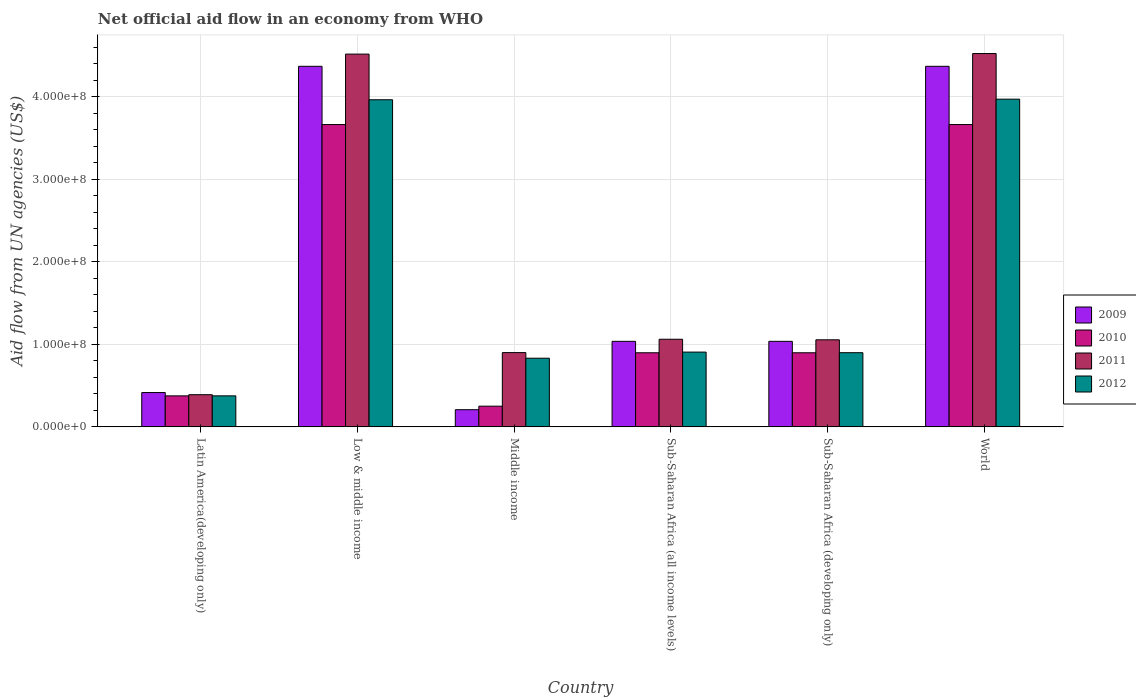How many groups of bars are there?
Make the answer very short. 6. Are the number of bars on each tick of the X-axis equal?
Make the answer very short. Yes. How many bars are there on the 5th tick from the left?
Offer a terse response. 4. How many bars are there on the 1st tick from the right?
Your response must be concise. 4. What is the label of the 4th group of bars from the left?
Your answer should be very brief. Sub-Saharan Africa (all income levels). In how many cases, is the number of bars for a given country not equal to the number of legend labels?
Keep it short and to the point. 0. What is the net official aid flow in 2009 in Sub-Saharan Africa (developing only)?
Make the answer very short. 1.04e+08. Across all countries, what is the maximum net official aid flow in 2009?
Ensure brevity in your answer.  4.37e+08. Across all countries, what is the minimum net official aid flow in 2012?
Your answer should be very brief. 3.76e+07. In which country was the net official aid flow in 2011 minimum?
Provide a succinct answer. Latin America(developing only). What is the total net official aid flow in 2011 in the graph?
Provide a succinct answer. 1.24e+09. What is the difference between the net official aid flow in 2009 in Low & middle income and that in Sub-Saharan Africa (all income levels)?
Your response must be concise. 3.33e+08. What is the difference between the net official aid flow in 2009 in Sub-Saharan Africa (developing only) and the net official aid flow in 2011 in World?
Provide a succinct answer. -3.49e+08. What is the average net official aid flow in 2010 per country?
Offer a very short reply. 1.62e+08. What is the difference between the net official aid flow of/in 2012 and net official aid flow of/in 2011 in Latin America(developing only)?
Offer a very short reply. -1.40e+06. What is the ratio of the net official aid flow in 2011 in Sub-Saharan Africa (all income levels) to that in Sub-Saharan Africa (developing only)?
Give a very brief answer. 1.01. Is the net official aid flow in 2011 in Latin America(developing only) less than that in Sub-Saharan Africa (developing only)?
Keep it short and to the point. Yes. What is the difference between the highest and the second highest net official aid flow in 2009?
Your answer should be compact. 3.33e+08. What is the difference between the highest and the lowest net official aid flow in 2011?
Your answer should be very brief. 4.13e+08. Is the sum of the net official aid flow in 2009 in Latin America(developing only) and World greater than the maximum net official aid flow in 2011 across all countries?
Provide a short and direct response. Yes. Is it the case that in every country, the sum of the net official aid flow in 2009 and net official aid flow in 2012 is greater than the sum of net official aid flow in 2011 and net official aid flow in 2010?
Offer a very short reply. No. How many bars are there?
Your response must be concise. 24. What is the difference between two consecutive major ticks on the Y-axis?
Make the answer very short. 1.00e+08. Does the graph contain grids?
Your answer should be very brief. Yes. How many legend labels are there?
Make the answer very short. 4. How are the legend labels stacked?
Keep it short and to the point. Vertical. What is the title of the graph?
Your answer should be very brief. Net official aid flow in an economy from WHO. What is the label or title of the Y-axis?
Keep it short and to the point. Aid flow from UN agencies (US$). What is the Aid flow from UN agencies (US$) of 2009 in Latin America(developing only)?
Offer a very short reply. 4.16e+07. What is the Aid flow from UN agencies (US$) of 2010 in Latin America(developing only)?
Offer a terse response. 3.76e+07. What is the Aid flow from UN agencies (US$) of 2011 in Latin America(developing only)?
Your response must be concise. 3.90e+07. What is the Aid flow from UN agencies (US$) in 2012 in Latin America(developing only)?
Your answer should be compact. 3.76e+07. What is the Aid flow from UN agencies (US$) in 2009 in Low & middle income?
Provide a succinct answer. 4.37e+08. What is the Aid flow from UN agencies (US$) of 2010 in Low & middle income?
Your answer should be very brief. 3.66e+08. What is the Aid flow from UN agencies (US$) of 2011 in Low & middle income?
Offer a terse response. 4.52e+08. What is the Aid flow from UN agencies (US$) in 2012 in Low & middle income?
Keep it short and to the point. 3.96e+08. What is the Aid flow from UN agencies (US$) in 2009 in Middle income?
Provide a short and direct response. 2.08e+07. What is the Aid flow from UN agencies (US$) in 2010 in Middle income?
Provide a short and direct response. 2.51e+07. What is the Aid flow from UN agencies (US$) of 2011 in Middle income?
Your answer should be compact. 9.00e+07. What is the Aid flow from UN agencies (US$) of 2012 in Middle income?
Provide a succinct answer. 8.32e+07. What is the Aid flow from UN agencies (US$) in 2009 in Sub-Saharan Africa (all income levels)?
Your answer should be very brief. 1.04e+08. What is the Aid flow from UN agencies (US$) in 2010 in Sub-Saharan Africa (all income levels)?
Provide a succinct answer. 8.98e+07. What is the Aid flow from UN agencies (US$) in 2011 in Sub-Saharan Africa (all income levels)?
Give a very brief answer. 1.06e+08. What is the Aid flow from UN agencies (US$) in 2012 in Sub-Saharan Africa (all income levels)?
Ensure brevity in your answer.  9.06e+07. What is the Aid flow from UN agencies (US$) of 2009 in Sub-Saharan Africa (developing only)?
Offer a very short reply. 1.04e+08. What is the Aid flow from UN agencies (US$) of 2010 in Sub-Saharan Africa (developing only)?
Give a very brief answer. 8.98e+07. What is the Aid flow from UN agencies (US$) in 2011 in Sub-Saharan Africa (developing only)?
Offer a very short reply. 1.05e+08. What is the Aid flow from UN agencies (US$) in 2012 in Sub-Saharan Africa (developing only)?
Provide a short and direct response. 8.98e+07. What is the Aid flow from UN agencies (US$) of 2009 in World?
Offer a very short reply. 4.37e+08. What is the Aid flow from UN agencies (US$) of 2010 in World?
Your answer should be very brief. 3.66e+08. What is the Aid flow from UN agencies (US$) in 2011 in World?
Give a very brief answer. 4.52e+08. What is the Aid flow from UN agencies (US$) of 2012 in World?
Your answer should be very brief. 3.97e+08. Across all countries, what is the maximum Aid flow from UN agencies (US$) of 2009?
Offer a terse response. 4.37e+08. Across all countries, what is the maximum Aid flow from UN agencies (US$) of 2010?
Your answer should be very brief. 3.66e+08. Across all countries, what is the maximum Aid flow from UN agencies (US$) of 2011?
Offer a terse response. 4.52e+08. Across all countries, what is the maximum Aid flow from UN agencies (US$) in 2012?
Make the answer very short. 3.97e+08. Across all countries, what is the minimum Aid flow from UN agencies (US$) in 2009?
Keep it short and to the point. 2.08e+07. Across all countries, what is the minimum Aid flow from UN agencies (US$) in 2010?
Ensure brevity in your answer.  2.51e+07. Across all countries, what is the minimum Aid flow from UN agencies (US$) of 2011?
Ensure brevity in your answer.  3.90e+07. Across all countries, what is the minimum Aid flow from UN agencies (US$) of 2012?
Make the answer very short. 3.76e+07. What is the total Aid flow from UN agencies (US$) of 2009 in the graph?
Your answer should be very brief. 1.14e+09. What is the total Aid flow from UN agencies (US$) of 2010 in the graph?
Keep it short and to the point. 9.75e+08. What is the total Aid flow from UN agencies (US$) of 2011 in the graph?
Ensure brevity in your answer.  1.24e+09. What is the total Aid flow from UN agencies (US$) of 2012 in the graph?
Give a very brief answer. 1.09e+09. What is the difference between the Aid flow from UN agencies (US$) of 2009 in Latin America(developing only) and that in Low & middle income?
Give a very brief answer. -3.95e+08. What is the difference between the Aid flow from UN agencies (US$) of 2010 in Latin America(developing only) and that in Low & middle income?
Ensure brevity in your answer.  -3.29e+08. What is the difference between the Aid flow from UN agencies (US$) of 2011 in Latin America(developing only) and that in Low & middle income?
Give a very brief answer. -4.13e+08. What is the difference between the Aid flow from UN agencies (US$) in 2012 in Latin America(developing only) and that in Low & middle income?
Your response must be concise. -3.59e+08. What is the difference between the Aid flow from UN agencies (US$) of 2009 in Latin America(developing only) and that in Middle income?
Your answer should be compact. 2.08e+07. What is the difference between the Aid flow from UN agencies (US$) of 2010 in Latin America(developing only) and that in Middle income?
Keep it short and to the point. 1.25e+07. What is the difference between the Aid flow from UN agencies (US$) in 2011 in Latin America(developing only) and that in Middle income?
Keep it short and to the point. -5.10e+07. What is the difference between the Aid flow from UN agencies (US$) of 2012 in Latin America(developing only) and that in Middle income?
Offer a very short reply. -4.56e+07. What is the difference between the Aid flow from UN agencies (US$) in 2009 in Latin America(developing only) and that in Sub-Saharan Africa (all income levels)?
Provide a succinct answer. -6.20e+07. What is the difference between the Aid flow from UN agencies (US$) of 2010 in Latin America(developing only) and that in Sub-Saharan Africa (all income levels)?
Keep it short and to the point. -5.22e+07. What is the difference between the Aid flow from UN agencies (US$) of 2011 in Latin America(developing only) and that in Sub-Saharan Africa (all income levels)?
Give a very brief answer. -6.72e+07. What is the difference between the Aid flow from UN agencies (US$) in 2012 in Latin America(developing only) and that in Sub-Saharan Africa (all income levels)?
Keep it short and to the point. -5.30e+07. What is the difference between the Aid flow from UN agencies (US$) in 2009 in Latin America(developing only) and that in Sub-Saharan Africa (developing only)?
Ensure brevity in your answer.  -6.20e+07. What is the difference between the Aid flow from UN agencies (US$) in 2010 in Latin America(developing only) and that in Sub-Saharan Africa (developing only)?
Your answer should be very brief. -5.22e+07. What is the difference between the Aid flow from UN agencies (US$) in 2011 in Latin America(developing only) and that in Sub-Saharan Africa (developing only)?
Offer a very short reply. -6.65e+07. What is the difference between the Aid flow from UN agencies (US$) of 2012 in Latin America(developing only) and that in Sub-Saharan Africa (developing only)?
Keep it short and to the point. -5.23e+07. What is the difference between the Aid flow from UN agencies (US$) of 2009 in Latin America(developing only) and that in World?
Your answer should be very brief. -3.95e+08. What is the difference between the Aid flow from UN agencies (US$) of 2010 in Latin America(developing only) and that in World?
Your response must be concise. -3.29e+08. What is the difference between the Aid flow from UN agencies (US$) in 2011 in Latin America(developing only) and that in World?
Provide a succinct answer. -4.13e+08. What is the difference between the Aid flow from UN agencies (US$) of 2012 in Latin America(developing only) and that in World?
Your answer should be very brief. -3.59e+08. What is the difference between the Aid flow from UN agencies (US$) of 2009 in Low & middle income and that in Middle income?
Make the answer very short. 4.16e+08. What is the difference between the Aid flow from UN agencies (US$) in 2010 in Low & middle income and that in Middle income?
Ensure brevity in your answer.  3.41e+08. What is the difference between the Aid flow from UN agencies (US$) of 2011 in Low & middle income and that in Middle income?
Keep it short and to the point. 3.62e+08. What is the difference between the Aid flow from UN agencies (US$) of 2012 in Low & middle income and that in Middle income?
Your answer should be very brief. 3.13e+08. What is the difference between the Aid flow from UN agencies (US$) in 2009 in Low & middle income and that in Sub-Saharan Africa (all income levels)?
Your answer should be compact. 3.33e+08. What is the difference between the Aid flow from UN agencies (US$) of 2010 in Low & middle income and that in Sub-Saharan Africa (all income levels)?
Your response must be concise. 2.76e+08. What is the difference between the Aid flow from UN agencies (US$) of 2011 in Low & middle income and that in Sub-Saharan Africa (all income levels)?
Offer a very short reply. 3.45e+08. What is the difference between the Aid flow from UN agencies (US$) in 2012 in Low & middle income and that in Sub-Saharan Africa (all income levels)?
Offer a very short reply. 3.06e+08. What is the difference between the Aid flow from UN agencies (US$) of 2009 in Low & middle income and that in Sub-Saharan Africa (developing only)?
Offer a terse response. 3.33e+08. What is the difference between the Aid flow from UN agencies (US$) of 2010 in Low & middle income and that in Sub-Saharan Africa (developing only)?
Your answer should be compact. 2.76e+08. What is the difference between the Aid flow from UN agencies (US$) in 2011 in Low & middle income and that in Sub-Saharan Africa (developing only)?
Ensure brevity in your answer.  3.46e+08. What is the difference between the Aid flow from UN agencies (US$) of 2012 in Low & middle income and that in Sub-Saharan Africa (developing only)?
Keep it short and to the point. 3.06e+08. What is the difference between the Aid flow from UN agencies (US$) in 2009 in Low & middle income and that in World?
Keep it short and to the point. 0. What is the difference between the Aid flow from UN agencies (US$) in 2011 in Low & middle income and that in World?
Your response must be concise. -6.70e+05. What is the difference between the Aid flow from UN agencies (US$) of 2012 in Low & middle income and that in World?
Offer a very short reply. -7.20e+05. What is the difference between the Aid flow from UN agencies (US$) of 2009 in Middle income and that in Sub-Saharan Africa (all income levels)?
Make the answer very short. -8.28e+07. What is the difference between the Aid flow from UN agencies (US$) in 2010 in Middle income and that in Sub-Saharan Africa (all income levels)?
Keep it short and to the point. -6.47e+07. What is the difference between the Aid flow from UN agencies (US$) of 2011 in Middle income and that in Sub-Saharan Africa (all income levels)?
Provide a succinct answer. -1.62e+07. What is the difference between the Aid flow from UN agencies (US$) of 2012 in Middle income and that in Sub-Saharan Africa (all income levels)?
Keep it short and to the point. -7.39e+06. What is the difference between the Aid flow from UN agencies (US$) in 2009 in Middle income and that in Sub-Saharan Africa (developing only)?
Ensure brevity in your answer.  -8.28e+07. What is the difference between the Aid flow from UN agencies (US$) in 2010 in Middle income and that in Sub-Saharan Africa (developing only)?
Provide a succinct answer. -6.47e+07. What is the difference between the Aid flow from UN agencies (US$) of 2011 in Middle income and that in Sub-Saharan Africa (developing only)?
Ensure brevity in your answer.  -1.55e+07. What is the difference between the Aid flow from UN agencies (US$) in 2012 in Middle income and that in Sub-Saharan Africa (developing only)?
Give a very brief answer. -6.67e+06. What is the difference between the Aid flow from UN agencies (US$) of 2009 in Middle income and that in World?
Keep it short and to the point. -4.16e+08. What is the difference between the Aid flow from UN agencies (US$) of 2010 in Middle income and that in World?
Offer a terse response. -3.41e+08. What is the difference between the Aid flow from UN agencies (US$) of 2011 in Middle income and that in World?
Keep it short and to the point. -3.62e+08. What is the difference between the Aid flow from UN agencies (US$) of 2012 in Middle income and that in World?
Keep it short and to the point. -3.14e+08. What is the difference between the Aid flow from UN agencies (US$) in 2009 in Sub-Saharan Africa (all income levels) and that in Sub-Saharan Africa (developing only)?
Offer a very short reply. 0. What is the difference between the Aid flow from UN agencies (US$) in 2010 in Sub-Saharan Africa (all income levels) and that in Sub-Saharan Africa (developing only)?
Offer a very short reply. 0. What is the difference between the Aid flow from UN agencies (US$) in 2011 in Sub-Saharan Africa (all income levels) and that in Sub-Saharan Africa (developing only)?
Your response must be concise. 6.70e+05. What is the difference between the Aid flow from UN agencies (US$) in 2012 in Sub-Saharan Africa (all income levels) and that in Sub-Saharan Africa (developing only)?
Your answer should be very brief. 7.20e+05. What is the difference between the Aid flow from UN agencies (US$) in 2009 in Sub-Saharan Africa (all income levels) and that in World?
Ensure brevity in your answer.  -3.33e+08. What is the difference between the Aid flow from UN agencies (US$) of 2010 in Sub-Saharan Africa (all income levels) and that in World?
Ensure brevity in your answer.  -2.76e+08. What is the difference between the Aid flow from UN agencies (US$) in 2011 in Sub-Saharan Africa (all income levels) and that in World?
Offer a terse response. -3.46e+08. What is the difference between the Aid flow from UN agencies (US$) of 2012 in Sub-Saharan Africa (all income levels) and that in World?
Ensure brevity in your answer.  -3.06e+08. What is the difference between the Aid flow from UN agencies (US$) in 2009 in Sub-Saharan Africa (developing only) and that in World?
Provide a short and direct response. -3.33e+08. What is the difference between the Aid flow from UN agencies (US$) in 2010 in Sub-Saharan Africa (developing only) and that in World?
Your answer should be very brief. -2.76e+08. What is the difference between the Aid flow from UN agencies (US$) of 2011 in Sub-Saharan Africa (developing only) and that in World?
Your answer should be very brief. -3.47e+08. What is the difference between the Aid flow from UN agencies (US$) of 2012 in Sub-Saharan Africa (developing only) and that in World?
Ensure brevity in your answer.  -3.07e+08. What is the difference between the Aid flow from UN agencies (US$) of 2009 in Latin America(developing only) and the Aid flow from UN agencies (US$) of 2010 in Low & middle income?
Make the answer very short. -3.25e+08. What is the difference between the Aid flow from UN agencies (US$) of 2009 in Latin America(developing only) and the Aid flow from UN agencies (US$) of 2011 in Low & middle income?
Offer a very short reply. -4.10e+08. What is the difference between the Aid flow from UN agencies (US$) of 2009 in Latin America(developing only) and the Aid flow from UN agencies (US$) of 2012 in Low & middle income?
Provide a succinct answer. -3.55e+08. What is the difference between the Aid flow from UN agencies (US$) of 2010 in Latin America(developing only) and the Aid flow from UN agencies (US$) of 2011 in Low & middle income?
Make the answer very short. -4.14e+08. What is the difference between the Aid flow from UN agencies (US$) of 2010 in Latin America(developing only) and the Aid flow from UN agencies (US$) of 2012 in Low & middle income?
Your answer should be compact. -3.59e+08. What is the difference between the Aid flow from UN agencies (US$) of 2011 in Latin America(developing only) and the Aid flow from UN agencies (US$) of 2012 in Low & middle income?
Provide a short and direct response. -3.57e+08. What is the difference between the Aid flow from UN agencies (US$) of 2009 in Latin America(developing only) and the Aid flow from UN agencies (US$) of 2010 in Middle income?
Keep it short and to the point. 1.65e+07. What is the difference between the Aid flow from UN agencies (US$) in 2009 in Latin America(developing only) and the Aid flow from UN agencies (US$) in 2011 in Middle income?
Provide a succinct answer. -4.84e+07. What is the difference between the Aid flow from UN agencies (US$) in 2009 in Latin America(developing only) and the Aid flow from UN agencies (US$) in 2012 in Middle income?
Provide a succinct answer. -4.16e+07. What is the difference between the Aid flow from UN agencies (US$) of 2010 in Latin America(developing only) and the Aid flow from UN agencies (US$) of 2011 in Middle income?
Provide a succinct answer. -5.24e+07. What is the difference between the Aid flow from UN agencies (US$) in 2010 in Latin America(developing only) and the Aid flow from UN agencies (US$) in 2012 in Middle income?
Your response must be concise. -4.56e+07. What is the difference between the Aid flow from UN agencies (US$) of 2011 in Latin America(developing only) and the Aid flow from UN agencies (US$) of 2012 in Middle income?
Your answer should be very brief. -4.42e+07. What is the difference between the Aid flow from UN agencies (US$) in 2009 in Latin America(developing only) and the Aid flow from UN agencies (US$) in 2010 in Sub-Saharan Africa (all income levels)?
Provide a succinct answer. -4.82e+07. What is the difference between the Aid flow from UN agencies (US$) of 2009 in Latin America(developing only) and the Aid flow from UN agencies (US$) of 2011 in Sub-Saharan Africa (all income levels)?
Offer a very short reply. -6.46e+07. What is the difference between the Aid flow from UN agencies (US$) in 2009 in Latin America(developing only) and the Aid flow from UN agencies (US$) in 2012 in Sub-Saharan Africa (all income levels)?
Your answer should be very brief. -4.90e+07. What is the difference between the Aid flow from UN agencies (US$) of 2010 in Latin America(developing only) and the Aid flow from UN agencies (US$) of 2011 in Sub-Saharan Africa (all income levels)?
Your answer should be very brief. -6.86e+07. What is the difference between the Aid flow from UN agencies (US$) of 2010 in Latin America(developing only) and the Aid flow from UN agencies (US$) of 2012 in Sub-Saharan Africa (all income levels)?
Provide a succinct answer. -5.30e+07. What is the difference between the Aid flow from UN agencies (US$) of 2011 in Latin America(developing only) and the Aid flow from UN agencies (US$) of 2012 in Sub-Saharan Africa (all income levels)?
Keep it short and to the point. -5.16e+07. What is the difference between the Aid flow from UN agencies (US$) of 2009 in Latin America(developing only) and the Aid flow from UN agencies (US$) of 2010 in Sub-Saharan Africa (developing only)?
Your answer should be compact. -4.82e+07. What is the difference between the Aid flow from UN agencies (US$) of 2009 in Latin America(developing only) and the Aid flow from UN agencies (US$) of 2011 in Sub-Saharan Africa (developing only)?
Offer a terse response. -6.39e+07. What is the difference between the Aid flow from UN agencies (US$) of 2009 in Latin America(developing only) and the Aid flow from UN agencies (US$) of 2012 in Sub-Saharan Africa (developing only)?
Your answer should be very brief. -4.83e+07. What is the difference between the Aid flow from UN agencies (US$) of 2010 in Latin America(developing only) and the Aid flow from UN agencies (US$) of 2011 in Sub-Saharan Africa (developing only)?
Provide a short and direct response. -6.79e+07. What is the difference between the Aid flow from UN agencies (US$) of 2010 in Latin America(developing only) and the Aid flow from UN agencies (US$) of 2012 in Sub-Saharan Africa (developing only)?
Make the answer very short. -5.23e+07. What is the difference between the Aid flow from UN agencies (US$) of 2011 in Latin America(developing only) and the Aid flow from UN agencies (US$) of 2012 in Sub-Saharan Africa (developing only)?
Provide a short and direct response. -5.09e+07. What is the difference between the Aid flow from UN agencies (US$) in 2009 in Latin America(developing only) and the Aid flow from UN agencies (US$) in 2010 in World?
Offer a very short reply. -3.25e+08. What is the difference between the Aid flow from UN agencies (US$) of 2009 in Latin America(developing only) and the Aid flow from UN agencies (US$) of 2011 in World?
Keep it short and to the point. -4.11e+08. What is the difference between the Aid flow from UN agencies (US$) of 2009 in Latin America(developing only) and the Aid flow from UN agencies (US$) of 2012 in World?
Make the answer very short. -3.55e+08. What is the difference between the Aid flow from UN agencies (US$) in 2010 in Latin America(developing only) and the Aid flow from UN agencies (US$) in 2011 in World?
Ensure brevity in your answer.  -4.15e+08. What is the difference between the Aid flow from UN agencies (US$) of 2010 in Latin America(developing only) and the Aid flow from UN agencies (US$) of 2012 in World?
Provide a short and direct response. -3.59e+08. What is the difference between the Aid flow from UN agencies (US$) in 2011 in Latin America(developing only) and the Aid flow from UN agencies (US$) in 2012 in World?
Offer a terse response. -3.58e+08. What is the difference between the Aid flow from UN agencies (US$) in 2009 in Low & middle income and the Aid flow from UN agencies (US$) in 2010 in Middle income?
Offer a terse response. 4.12e+08. What is the difference between the Aid flow from UN agencies (US$) of 2009 in Low & middle income and the Aid flow from UN agencies (US$) of 2011 in Middle income?
Your answer should be compact. 3.47e+08. What is the difference between the Aid flow from UN agencies (US$) in 2009 in Low & middle income and the Aid flow from UN agencies (US$) in 2012 in Middle income?
Provide a succinct answer. 3.54e+08. What is the difference between the Aid flow from UN agencies (US$) in 2010 in Low & middle income and the Aid flow from UN agencies (US$) in 2011 in Middle income?
Your response must be concise. 2.76e+08. What is the difference between the Aid flow from UN agencies (US$) of 2010 in Low & middle income and the Aid flow from UN agencies (US$) of 2012 in Middle income?
Your answer should be compact. 2.83e+08. What is the difference between the Aid flow from UN agencies (US$) of 2011 in Low & middle income and the Aid flow from UN agencies (US$) of 2012 in Middle income?
Provide a short and direct response. 3.68e+08. What is the difference between the Aid flow from UN agencies (US$) of 2009 in Low & middle income and the Aid flow from UN agencies (US$) of 2010 in Sub-Saharan Africa (all income levels)?
Your answer should be compact. 3.47e+08. What is the difference between the Aid flow from UN agencies (US$) in 2009 in Low & middle income and the Aid flow from UN agencies (US$) in 2011 in Sub-Saharan Africa (all income levels)?
Keep it short and to the point. 3.31e+08. What is the difference between the Aid flow from UN agencies (US$) of 2009 in Low & middle income and the Aid flow from UN agencies (US$) of 2012 in Sub-Saharan Africa (all income levels)?
Provide a short and direct response. 3.46e+08. What is the difference between the Aid flow from UN agencies (US$) of 2010 in Low & middle income and the Aid flow from UN agencies (US$) of 2011 in Sub-Saharan Africa (all income levels)?
Give a very brief answer. 2.60e+08. What is the difference between the Aid flow from UN agencies (US$) in 2010 in Low & middle income and the Aid flow from UN agencies (US$) in 2012 in Sub-Saharan Africa (all income levels)?
Ensure brevity in your answer.  2.76e+08. What is the difference between the Aid flow from UN agencies (US$) in 2011 in Low & middle income and the Aid flow from UN agencies (US$) in 2012 in Sub-Saharan Africa (all income levels)?
Offer a terse response. 3.61e+08. What is the difference between the Aid flow from UN agencies (US$) in 2009 in Low & middle income and the Aid flow from UN agencies (US$) in 2010 in Sub-Saharan Africa (developing only)?
Provide a succinct answer. 3.47e+08. What is the difference between the Aid flow from UN agencies (US$) of 2009 in Low & middle income and the Aid flow from UN agencies (US$) of 2011 in Sub-Saharan Africa (developing only)?
Keep it short and to the point. 3.31e+08. What is the difference between the Aid flow from UN agencies (US$) of 2009 in Low & middle income and the Aid flow from UN agencies (US$) of 2012 in Sub-Saharan Africa (developing only)?
Keep it short and to the point. 3.47e+08. What is the difference between the Aid flow from UN agencies (US$) in 2010 in Low & middle income and the Aid flow from UN agencies (US$) in 2011 in Sub-Saharan Africa (developing only)?
Your response must be concise. 2.61e+08. What is the difference between the Aid flow from UN agencies (US$) of 2010 in Low & middle income and the Aid flow from UN agencies (US$) of 2012 in Sub-Saharan Africa (developing only)?
Your answer should be compact. 2.76e+08. What is the difference between the Aid flow from UN agencies (US$) of 2011 in Low & middle income and the Aid flow from UN agencies (US$) of 2012 in Sub-Saharan Africa (developing only)?
Your answer should be compact. 3.62e+08. What is the difference between the Aid flow from UN agencies (US$) of 2009 in Low & middle income and the Aid flow from UN agencies (US$) of 2010 in World?
Make the answer very short. 7.06e+07. What is the difference between the Aid flow from UN agencies (US$) in 2009 in Low & middle income and the Aid flow from UN agencies (US$) in 2011 in World?
Your answer should be very brief. -1.55e+07. What is the difference between the Aid flow from UN agencies (US$) in 2009 in Low & middle income and the Aid flow from UN agencies (US$) in 2012 in World?
Provide a succinct answer. 3.98e+07. What is the difference between the Aid flow from UN agencies (US$) in 2010 in Low & middle income and the Aid flow from UN agencies (US$) in 2011 in World?
Provide a short and direct response. -8.60e+07. What is the difference between the Aid flow from UN agencies (US$) in 2010 in Low & middle income and the Aid flow from UN agencies (US$) in 2012 in World?
Your answer should be compact. -3.08e+07. What is the difference between the Aid flow from UN agencies (US$) of 2011 in Low & middle income and the Aid flow from UN agencies (US$) of 2012 in World?
Your answer should be compact. 5.46e+07. What is the difference between the Aid flow from UN agencies (US$) of 2009 in Middle income and the Aid flow from UN agencies (US$) of 2010 in Sub-Saharan Africa (all income levels)?
Provide a short and direct response. -6.90e+07. What is the difference between the Aid flow from UN agencies (US$) of 2009 in Middle income and the Aid flow from UN agencies (US$) of 2011 in Sub-Saharan Africa (all income levels)?
Keep it short and to the point. -8.54e+07. What is the difference between the Aid flow from UN agencies (US$) of 2009 in Middle income and the Aid flow from UN agencies (US$) of 2012 in Sub-Saharan Africa (all income levels)?
Give a very brief answer. -6.98e+07. What is the difference between the Aid flow from UN agencies (US$) in 2010 in Middle income and the Aid flow from UN agencies (US$) in 2011 in Sub-Saharan Africa (all income levels)?
Make the answer very short. -8.11e+07. What is the difference between the Aid flow from UN agencies (US$) of 2010 in Middle income and the Aid flow from UN agencies (US$) of 2012 in Sub-Saharan Africa (all income levels)?
Keep it short and to the point. -6.55e+07. What is the difference between the Aid flow from UN agencies (US$) in 2011 in Middle income and the Aid flow from UN agencies (US$) in 2012 in Sub-Saharan Africa (all income levels)?
Give a very brief answer. -5.90e+05. What is the difference between the Aid flow from UN agencies (US$) in 2009 in Middle income and the Aid flow from UN agencies (US$) in 2010 in Sub-Saharan Africa (developing only)?
Your answer should be very brief. -6.90e+07. What is the difference between the Aid flow from UN agencies (US$) in 2009 in Middle income and the Aid flow from UN agencies (US$) in 2011 in Sub-Saharan Africa (developing only)?
Offer a very short reply. -8.47e+07. What is the difference between the Aid flow from UN agencies (US$) of 2009 in Middle income and the Aid flow from UN agencies (US$) of 2012 in Sub-Saharan Africa (developing only)?
Offer a very short reply. -6.90e+07. What is the difference between the Aid flow from UN agencies (US$) of 2010 in Middle income and the Aid flow from UN agencies (US$) of 2011 in Sub-Saharan Africa (developing only)?
Your answer should be compact. -8.04e+07. What is the difference between the Aid flow from UN agencies (US$) of 2010 in Middle income and the Aid flow from UN agencies (US$) of 2012 in Sub-Saharan Africa (developing only)?
Offer a terse response. -6.48e+07. What is the difference between the Aid flow from UN agencies (US$) in 2011 in Middle income and the Aid flow from UN agencies (US$) in 2012 in Sub-Saharan Africa (developing only)?
Your response must be concise. 1.30e+05. What is the difference between the Aid flow from UN agencies (US$) of 2009 in Middle income and the Aid flow from UN agencies (US$) of 2010 in World?
Give a very brief answer. -3.45e+08. What is the difference between the Aid flow from UN agencies (US$) in 2009 in Middle income and the Aid flow from UN agencies (US$) in 2011 in World?
Your answer should be very brief. -4.31e+08. What is the difference between the Aid flow from UN agencies (US$) in 2009 in Middle income and the Aid flow from UN agencies (US$) in 2012 in World?
Your answer should be compact. -3.76e+08. What is the difference between the Aid flow from UN agencies (US$) in 2010 in Middle income and the Aid flow from UN agencies (US$) in 2011 in World?
Provide a succinct answer. -4.27e+08. What is the difference between the Aid flow from UN agencies (US$) of 2010 in Middle income and the Aid flow from UN agencies (US$) of 2012 in World?
Provide a succinct answer. -3.72e+08. What is the difference between the Aid flow from UN agencies (US$) of 2011 in Middle income and the Aid flow from UN agencies (US$) of 2012 in World?
Your answer should be compact. -3.07e+08. What is the difference between the Aid flow from UN agencies (US$) in 2009 in Sub-Saharan Africa (all income levels) and the Aid flow from UN agencies (US$) in 2010 in Sub-Saharan Africa (developing only)?
Offer a very short reply. 1.39e+07. What is the difference between the Aid flow from UN agencies (US$) of 2009 in Sub-Saharan Africa (all income levels) and the Aid flow from UN agencies (US$) of 2011 in Sub-Saharan Africa (developing only)?
Ensure brevity in your answer.  -1.86e+06. What is the difference between the Aid flow from UN agencies (US$) of 2009 in Sub-Saharan Africa (all income levels) and the Aid flow from UN agencies (US$) of 2012 in Sub-Saharan Africa (developing only)?
Your answer should be very brief. 1.38e+07. What is the difference between the Aid flow from UN agencies (US$) in 2010 in Sub-Saharan Africa (all income levels) and the Aid flow from UN agencies (US$) in 2011 in Sub-Saharan Africa (developing only)?
Your answer should be very brief. -1.57e+07. What is the difference between the Aid flow from UN agencies (US$) of 2010 in Sub-Saharan Africa (all income levels) and the Aid flow from UN agencies (US$) of 2012 in Sub-Saharan Africa (developing only)?
Ensure brevity in your answer.  -9.00e+04. What is the difference between the Aid flow from UN agencies (US$) of 2011 in Sub-Saharan Africa (all income levels) and the Aid flow from UN agencies (US$) of 2012 in Sub-Saharan Africa (developing only)?
Offer a very short reply. 1.63e+07. What is the difference between the Aid flow from UN agencies (US$) in 2009 in Sub-Saharan Africa (all income levels) and the Aid flow from UN agencies (US$) in 2010 in World?
Offer a terse response. -2.63e+08. What is the difference between the Aid flow from UN agencies (US$) in 2009 in Sub-Saharan Africa (all income levels) and the Aid flow from UN agencies (US$) in 2011 in World?
Your answer should be compact. -3.49e+08. What is the difference between the Aid flow from UN agencies (US$) in 2009 in Sub-Saharan Africa (all income levels) and the Aid flow from UN agencies (US$) in 2012 in World?
Provide a succinct answer. -2.93e+08. What is the difference between the Aid flow from UN agencies (US$) of 2010 in Sub-Saharan Africa (all income levels) and the Aid flow from UN agencies (US$) of 2011 in World?
Offer a terse response. -3.62e+08. What is the difference between the Aid flow from UN agencies (US$) of 2010 in Sub-Saharan Africa (all income levels) and the Aid flow from UN agencies (US$) of 2012 in World?
Keep it short and to the point. -3.07e+08. What is the difference between the Aid flow from UN agencies (US$) of 2011 in Sub-Saharan Africa (all income levels) and the Aid flow from UN agencies (US$) of 2012 in World?
Your answer should be very brief. -2.91e+08. What is the difference between the Aid flow from UN agencies (US$) in 2009 in Sub-Saharan Africa (developing only) and the Aid flow from UN agencies (US$) in 2010 in World?
Your answer should be compact. -2.63e+08. What is the difference between the Aid flow from UN agencies (US$) in 2009 in Sub-Saharan Africa (developing only) and the Aid flow from UN agencies (US$) in 2011 in World?
Your answer should be compact. -3.49e+08. What is the difference between the Aid flow from UN agencies (US$) in 2009 in Sub-Saharan Africa (developing only) and the Aid flow from UN agencies (US$) in 2012 in World?
Your answer should be very brief. -2.93e+08. What is the difference between the Aid flow from UN agencies (US$) of 2010 in Sub-Saharan Africa (developing only) and the Aid flow from UN agencies (US$) of 2011 in World?
Ensure brevity in your answer.  -3.62e+08. What is the difference between the Aid flow from UN agencies (US$) in 2010 in Sub-Saharan Africa (developing only) and the Aid flow from UN agencies (US$) in 2012 in World?
Provide a short and direct response. -3.07e+08. What is the difference between the Aid flow from UN agencies (US$) of 2011 in Sub-Saharan Africa (developing only) and the Aid flow from UN agencies (US$) of 2012 in World?
Offer a terse response. -2.92e+08. What is the average Aid flow from UN agencies (US$) of 2009 per country?
Your response must be concise. 1.91e+08. What is the average Aid flow from UN agencies (US$) in 2010 per country?
Ensure brevity in your answer.  1.62e+08. What is the average Aid flow from UN agencies (US$) in 2011 per country?
Offer a terse response. 2.07e+08. What is the average Aid flow from UN agencies (US$) in 2012 per country?
Your response must be concise. 1.82e+08. What is the difference between the Aid flow from UN agencies (US$) of 2009 and Aid flow from UN agencies (US$) of 2010 in Latin America(developing only)?
Ensure brevity in your answer.  4.01e+06. What is the difference between the Aid flow from UN agencies (US$) of 2009 and Aid flow from UN agencies (US$) of 2011 in Latin America(developing only)?
Provide a short and direct response. 2.59e+06. What is the difference between the Aid flow from UN agencies (US$) of 2009 and Aid flow from UN agencies (US$) of 2012 in Latin America(developing only)?
Give a very brief answer. 3.99e+06. What is the difference between the Aid flow from UN agencies (US$) of 2010 and Aid flow from UN agencies (US$) of 2011 in Latin America(developing only)?
Your answer should be very brief. -1.42e+06. What is the difference between the Aid flow from UN agencies (US$) in 2010 and Aid flow from UN agencies (US$) in 2012 in Latin America(developing only)?
Offer a terse response. -2.00e+04. What is the difference between the Aid flow from UN agencies (US$) of 2011 and Aid flow from UN agencies (US$) of 2012 in Latin America(developing only)?
Provide a short and direct response. 1.40e+06. What is the difference between the Aid flow from UN agencies (US$) in 2009 and Aid flow from UN agencies (US$) in 2010 in Low & middle income?
Keep it short and to the point. 7.06e+07. What is the difference between the Aid flow from UN agencies (US$) of 2009 and Aid flow from UN agencies (US$) of 2011 in Low & middle income?
Provide a succinct answer. -1.48e+07. What is the difference between the Aid flow from UN agencies (US$) of 2009 and Aid flow from UN agencies (US$) of 2012 in Low & middle income?
Your answer should be very brief. 4.05e+07. What is the difference between the Aid flow from UN agencies (US$) of 2010 and Aid flow from UN agencies (US$) of 2011 in Low & middle income?
Your answer should be compact. -8.54e+07. What is the difference between the Aid flow from UN agencies (US$) of 2010 and Aid flow from UN agencies (US$) of 2012 in Low & middle income?
Your answer should be compact. -3.00e+07. What is the difference between the Aid flow from UN agencies (US$) in 2011 and Aid flow from UN agencies (US$) in 2012 in Low & middle income?
Give a very brief answer. 5.53e+07. What is the difference between the Aid flow from UN agencies (US$) of 2009 and Aid flow from UN agencies (US$) of 2010 in Middle income?
Ensure brevity in your answer.  -4.27e+06. What is the difference between the Aid flow from UN agencies (US$) in 2009 and Aid flow from UN agencies (US$) in 2011 in Middle income?
Ensure brevity in your answer.  -6.92e+07. What is the difference between the Aid flow from UN agencies (US$) in 2009 and Aid flow from UN agencies (US$) in 2012 in Middle income?
Keep it short and to the point. -6.24e+07. What is the difference between the Aid flow from UN agencies (US$) in 2010 and Aid flow from UN agencies (US$) in 2011 in Middle income?
Your answer should be very brief. -6.49e+07. What is the difference between the Aid flow from UN agencies (US$) of 2010 and Aid flow from UN agencies (US$) of 2012 in Middle income?
Keep it short and to the point. -5.81e+07. What is the difference between the Aid flow from UN agencies (US$) of 2011 and Aid flow from UN agencies (US$) of 2012 in Middle income?
Your response must be concise. 6.80e+06. What is the difference between the Aid flow from UN agencies (US$) of 2009 and Aid flow from UN agencies (US$) of 2010 in Sub-Saharan Africa (all income levels)?
Ensure brevity in your answer.  1.39e+07. What is the difference between the Aid flow from UN agencies (US$) of 2009 and Aid flow from UN agencies (US$) of 2011 in Sub-Saharan Africa (all income levels)?
Provide a short and direct response. -2.53e+06. What is the difference between the Aid flow from UN agencies (US$) of 2009 and Aid flow from UN agencies (US$) of 2012 in Sub-Saharan Africa (all income levels)?
Provide a succinct answer. 1.30e+07. What is the difference between the Aid flow from UN agencies (US$) of 2010 and Aid flow from UN agencies (US$) of 2011 in Sub-Saharan Africa (all income levels)?
Your response must be concise. -1.64e+07. What is the difference between the Aid flow from UN agencies (US$) in 2010 and Aid flow from UN agencies (US$) in 2012 in Sub-Saharan Africa (all income levels)?
Your answer should be compact. -8.10e+05. What is the difference between the Aid flow from UN agencies (US$) in 2011 and Aid flow from UN agencies (US$) in 2012 in Sub-Saharan Africa (all income levels)?
Provide a short and direct response. 1.56e+07. What is the difference between the Aid flow from UN agencies (US$) in 2009 and Aid flow from UN agencies (US$) in 2010 in Sub-Saharan Africa (developing only)?
Keep it short and to the point. 1.39e+07. What is the difference between the Aid flow from UN agencies (US$) of 2009 and Aid flow from UN agencies (US$) of 2011 in Sub-Saharan Africa (developing only)?
Your answer should be compact. -1.86e+06. What is the difference between the Aid flow from UN agencies (US$) of 2009 and Aid flow from UN agencies (US$) of 2012 in Sub-Saharan Africa (developing only)?
Your answer should be very brief. 1.38e+07. What is the difference between the Aid flow from UN agencies (US$) in 2010 and Aid flow from UN agencies (US$) in 2011 in Sub-Saharan Africa (developing only)?
Ensure brevity in your answer.  -1.57e+07. What is the difference between the Aid flow from UN agencies (US$) in 2010 and Aid flow from UN agencies (US$) in 2012 in Sub-Saharan Africa (developing only)?
Your answer should be compact. -9.00e+04. What is the difference between the Aid flow from UN agencies (US$) in 2011 and Aid flow from UN agencies (US$) in 2012 in Sub-Saharan Africa (developing only)?
Keep it short and to the point. 1.56e+07. What is the difference between the Aid flow from UN agencies (US$) of 2009 and Aid flow from UN agencies (US$) of 2010 in World?
Provide a succinct answer. 7.06e+07. What is the difference between the Aid flow from UN agencies (US$) of 2009 and Aid flow from UN agencies (US$) of 2011 in World?
Your response must be concise. -1.55e+07. What is the difference between the Aid flow from UN agencies (US$) in 2009 and Aid flow from UN agencies (US$) in 2012 in World?
Give a very brief answer. 3.98e+07. What is the difference between the Aid flow from UN agencies (US$) in 2010 and Aid flow from UN agencies (US$) in 2011 in World?
Your response must be concise. -8.60e+07. What is the difference between the Aid flow from UN agencies (US$) of 2010 and Aid flow from UN agencies (US$) of 2012 in World?
Give a very brief answer. -3.08e+07. What is the difference between the Aid flow from UN agencies (US$) of 2011 and Aid flow from UN agencies (US$) of 2012 in World?
Offer a terse response. 5.53e+07. What is the ratio of the Aid flow from UN agencies (US$) of 2009 in Latin America(developing only) to that in Low & middle income?
Keep it short and to the point. 0.1. What is the ratio of the Aid flow from UN agencies (US$) in 2010 in Latin America(developing only) to that in Low & middle income?
Provide a short and direct response. 0.1. What is the ratio of the Aid flow from UN agencies (US$) of 2011 in Latin America(developing only) to that in Low & middle income?
Offer a very short reply. 0.09. What is the ratio of the Aid flow from UN agencies (US$) of 2012 in Latin America(developing only) to that in Low & middle income?
Your answer should be very brief. 0.09. What is the ratio of the Aid flow from UN agencies (US$) in 2009 in Latin America(developing only) to that in Middle income?
Your response must be concise. 2. What is the ratio of the Aid flow from UN agencies (US$) of 2010 in Latin America(developing only) to that in Middle income?
Your response must be concise. 1.5. What is the ratio of the Aid flow from UN agencies (US$) of 2011 in Latin America(developing only) to that in Middle income?
Your response must be concise. 0.43. What is the ratio of the Aid flow from UN agencies (US$) in 2012 in Latin America(developing only) to that in Middle income?
Your response must be concise. 0.45. What is the ratio of the Aid flow from UN agencies (US$) of 2009 in Latin America(developing only) to that in Sub-Saharan Africa (all income levels)?
Offer a terse response. 0.4. What is the ratio of the Aid flow from UN agencies (US$) of 2010 in Latin America(developing only) to that in Sub-Saharan Africa (all income levels)?
Keep it short and to the point. 0.42. What is the ratio of the Aid flow from UN agencies (US$) in 2011 in Latin America(developing only) to that in Sub-Saharan Africa (all income levels)?
Give a very brief answer. 0.37. What is the ratio of the Aid flow from UN agencies (US$) in 2012 in Latin America(developing only) to that in Sub-Saharan Africa (all income levels)?
Offer a terse response. 0.41. What is the ratio of the Aid flow from UN agencies (US$) of 2009 in Latin America(developing only) to that in Sub-Saharan Africa (developing only)?
Keep it short and to the point. 0.4. What is the ratio of the Aid flow from UN agencies (US$) in 2010 in Latin America(developing only) to that in Sub-Saharan Africa (developing only)?
Make the answer very short. 0.42. What is the ratio of the Aid flow from UN agencies (US$) in 2011 in Latin America(developing only) to that in Sub-Saharan Africa (developing only)?
Give a very brief answer. 0.37. What is the ratio of the Aid flow from UN agencies (US$) in 2012 in Latin America(developing only) to that in Sub-Saharan Africa (developing only)?
Your response must be concise. 0.42. What is the ratio of the Aid flow from UN agencies (US$) in 2009 in Latin America(developing only) to that in World?
Offer a very short reply. 0.1. What is the ratio of the Aid flow from UN agencies (US$) of 2010 in Latin America(developing only) to that in World?
Give a very brief answer. 0.1. What is the ratio of the Aid flow from UN agencies (US$) in 2011 in Latin America(developing only) to that in World?
Make the answer very short. 0.09. What is the ratio of the Aid flow from UN agencies (US$) of 2012 in Latin America(developing only) to that in World?
Provide a succinct answer. 0.09. What is the ratio of the Aid flow from UN agencies (US$) of 2009 in Low & middle income to that in Middle income?
Make the answer very short. 21. What is the ratio of the Aid flow from UN agencies (US$) in 2010 in Low & middle income to that in Middle income?
Keep it short and to the point. 14.61. What is the ratio of the Aid flow from UN agencies (US$) of 2011 in Low & middle income to that in Middle income?
Give a very brief answer. 5.02. What is the ratio of the Aid flow from UN agencies (US$) in 2012 in Low & middle income to that in Middle income?
Give a very brief answer. 4.76. What is the ratio of the Aid flow from UN agencies (US$) in 2009 in Low & middle income to that in Sub-Saharan Africa (all income levels)?
Provide a succinct answer. 4.22. What is the ratio of the Aid flow from UN agencies (US$) of 2010 in Low & middle income to that in Sub-Saharan Africa (all income levels)?
Your answer should be very brief. 4.08. What is the ratio of the Aid flow from UN agencies (US$) of 2011 in Low & middle income to that in Sub-Saharan Africa (all income levels)?
Provide a short and direct response. 4.25. What is the ratio of the Aid flow from UN agencies (US$) in 2012 in Low & middle income to that in Sub-Saharan Africa (all income levels)?
Keep it short and to the point. 4.38. What is the ratio of the Aid flow from UN agencies (US$) of 2009 in Low & middle income to that in Sub-Saharan Africa (developing only)?
Your response must be concise. 4.22. What is the ratio of the Aid flow from UN agencies (US$) of 2010 in Low & middle income to that in Sub-Saharan Africa (developing only)?
Ensure brevity in your answer.  4.08. What is the ratio of the Aid flow from UN agencies (US$) in 2011 in Low & middle income to that in Sub-Saharan Africa (developing only)?
Provide a short and direct response. 4.28. What is the ratio of the Aid flow from UN agencies (US$) in 2012 in Low & middle income to that in Sub-Saharan Africa (developing only)?
Provide a short and direct response. 4.41. What is the ratio of the Aid flow from UN agencies (US$) in 2009 in Low & middle income to that in World?
Keep it short and to the point. 1. What is the ratio of the Aid flow from UN agencies (US$) of 2011 in Low & middle income to that in World?
Give a very brief answer. 1. What is the ratio of the Aid flow from UN agencies (US$) of 2009 in Middle income to that in Sub-Saharan Africa (all income levels)?
Provide a short and direct response. 0.2. What is the ratio of the Aid flow from UN agencies (US$) in 2010 in Middle income to that in Sub-Saharan Africa (all income levels)?
Your response must be concise. 0.28. What is the ratio of the Aid flow from UN agencies (US$) of 2011 in Middle income to that in Sub-Saharan Africa (all income levels)?
Keep it short and to the point. 0.85. What is the ratio of the Aid flow from UN agencies (US$) in 2012 in Middle income to that in Sub-Saharan Africa (all income levels)?
Offer a terse response. 0.92. What is the ratio of the Aid flow from UN agencies (US$) of 2009 in Middle income to that in Sub-Saharan Africa (developing only)?
Keep it short and to the point. 0.2. What is the ratio of the Aid flow from UN agencies (US$) in 2010 in Middle income to that in Sub-Saharan Africa (developing only)?
Provide a short and direct response. 0.28. What is the ratio of the Aid flow from UN agencies (US$) in 2011 in Middle income to that in Sub-Saharan Africa (developing only)?
Provide a succinct answer. 0.85. What is the ratio of the Aid flow from UN agencies (US$) of 2012 in Middle income to that in Sub-Saharan Africa (developing only)?
Provide a short and direct response. 0.93. What is the ratio of the Aid flow from UN agencies (US$) in 2009 in Middle income to that in World?
Your response must be concise. 0.05. What is the ratio of the Aid flow from UN agencies (US$) of 2010 in Middle income to that in World?
Make the answer very short. 0.07. What is the ratio of the Aid flow from UN agencies (US$) in 2011 in Middle income to that in World?
Your answer should be very brief. 0.2. What is the ratio of the Aid flow from UN agencies (US$) in 2012 in Middle income to that in World?
Provide a short and direct response. 0.21. What is the ratio of the Aid flow from UN agencies (US$) of 2009 in Sub-Saharan Africa (all income levels) to that in Sub-Saharan Africa (developing only)?
Your answer should be very brief. 1. What is the ratio of the Aid flow from UN agencies (US$) of 2011 in Sub-Saharan Africa (all income levels) to that in Sub-Saharan Africa (developing only)?
Offer a terse response. 1.01. What is the ratio of the Aid flow from UN agencies (US$) in 2012 in Sub-Saharan Africa (all income levels) to that in Sub-Saharan Africa (developing only)?
Make the answer very short. 1.01. What is the ratio of the Aid flow from UN agencies (US$) of 2009 in Sub-Saharan Africa (all income levels) to that in World?
Keep it short and to the point. 0.24. What is the ratio of the Aid flow from UN agencies (US$) in 2010 in Sub-Saharan Africa (all income levels) to that in World?
Provide a short and direct response. 0.25. What is the ratio of the Aid flow from UN agencies (US$) in 2011 in Sub-Saharan Africa (all income levels) to that in World?
Ensure brevity in your answer.  0.23. What is the ratio of the Aid flow from UN agencies (US$) in 2012 in Sub-Saharan Africa (all income levels) to that in World?
Your response must be concise. 0.23. What is the ratio of the Aid flow from UN agencies (US$) in 2009 in Sub-Saharan Africa (developing only) to that in World?
Your response must be concise. 0.24. What is the ratio of the Aid flow from UN agencies (US$) of 2010 in Sub-Saharan Africa (developing only) to that in World?
Keep it short and to the point. 0.25. What is the ratio of the Aid flow from UN agencies (US$) of 2011 in Sub-Saharan Africa (developing only) to that in World?
Your answer should be compact. 0.23. What is the ratio of the Aid flow from UN agencies (US$) of 2012 in Sub-Saharan Africa (developing only) to that in World?
Offer a very short reply. 0.23. What is the difference between the highest and the second highest Aid flow from UN agencies (US$) of 2009?
Ensure brevity in your answer.  0. What is the difference between the highest and the second highest Aid flow from UN agencies (US$) in 2010?
Give a very brief answer. 0. What is the difference between the highest and the second highest Aid flow from UN agencies (US$) in 2011?
Provide a succinct answer. 6.70e+05. What is the difference between the highest and the second highest Aid flow from UN agencies (US$) in 2012?
Offer a terse response. 7.20e+05. What is the difference between the highest and the lowest Aid flow from UN agencies (US$) of 2009?
Provide a succinct answer. 4.16e+08. What is the difference between the highest and the lowest Aid flow from UN agencies (US$) of 2010?
Your answer should be compact. 3.41e+08. What is the difference between the highest and the lowest Aid flow from UN agencies (US$) in 2011?
Make the answer very short. 4.13e+08. What is the difference between the highest and the lowest Aid flow from UN agencies (US$) of 2012?
Your answer should be very brief. 3.59e+08. 